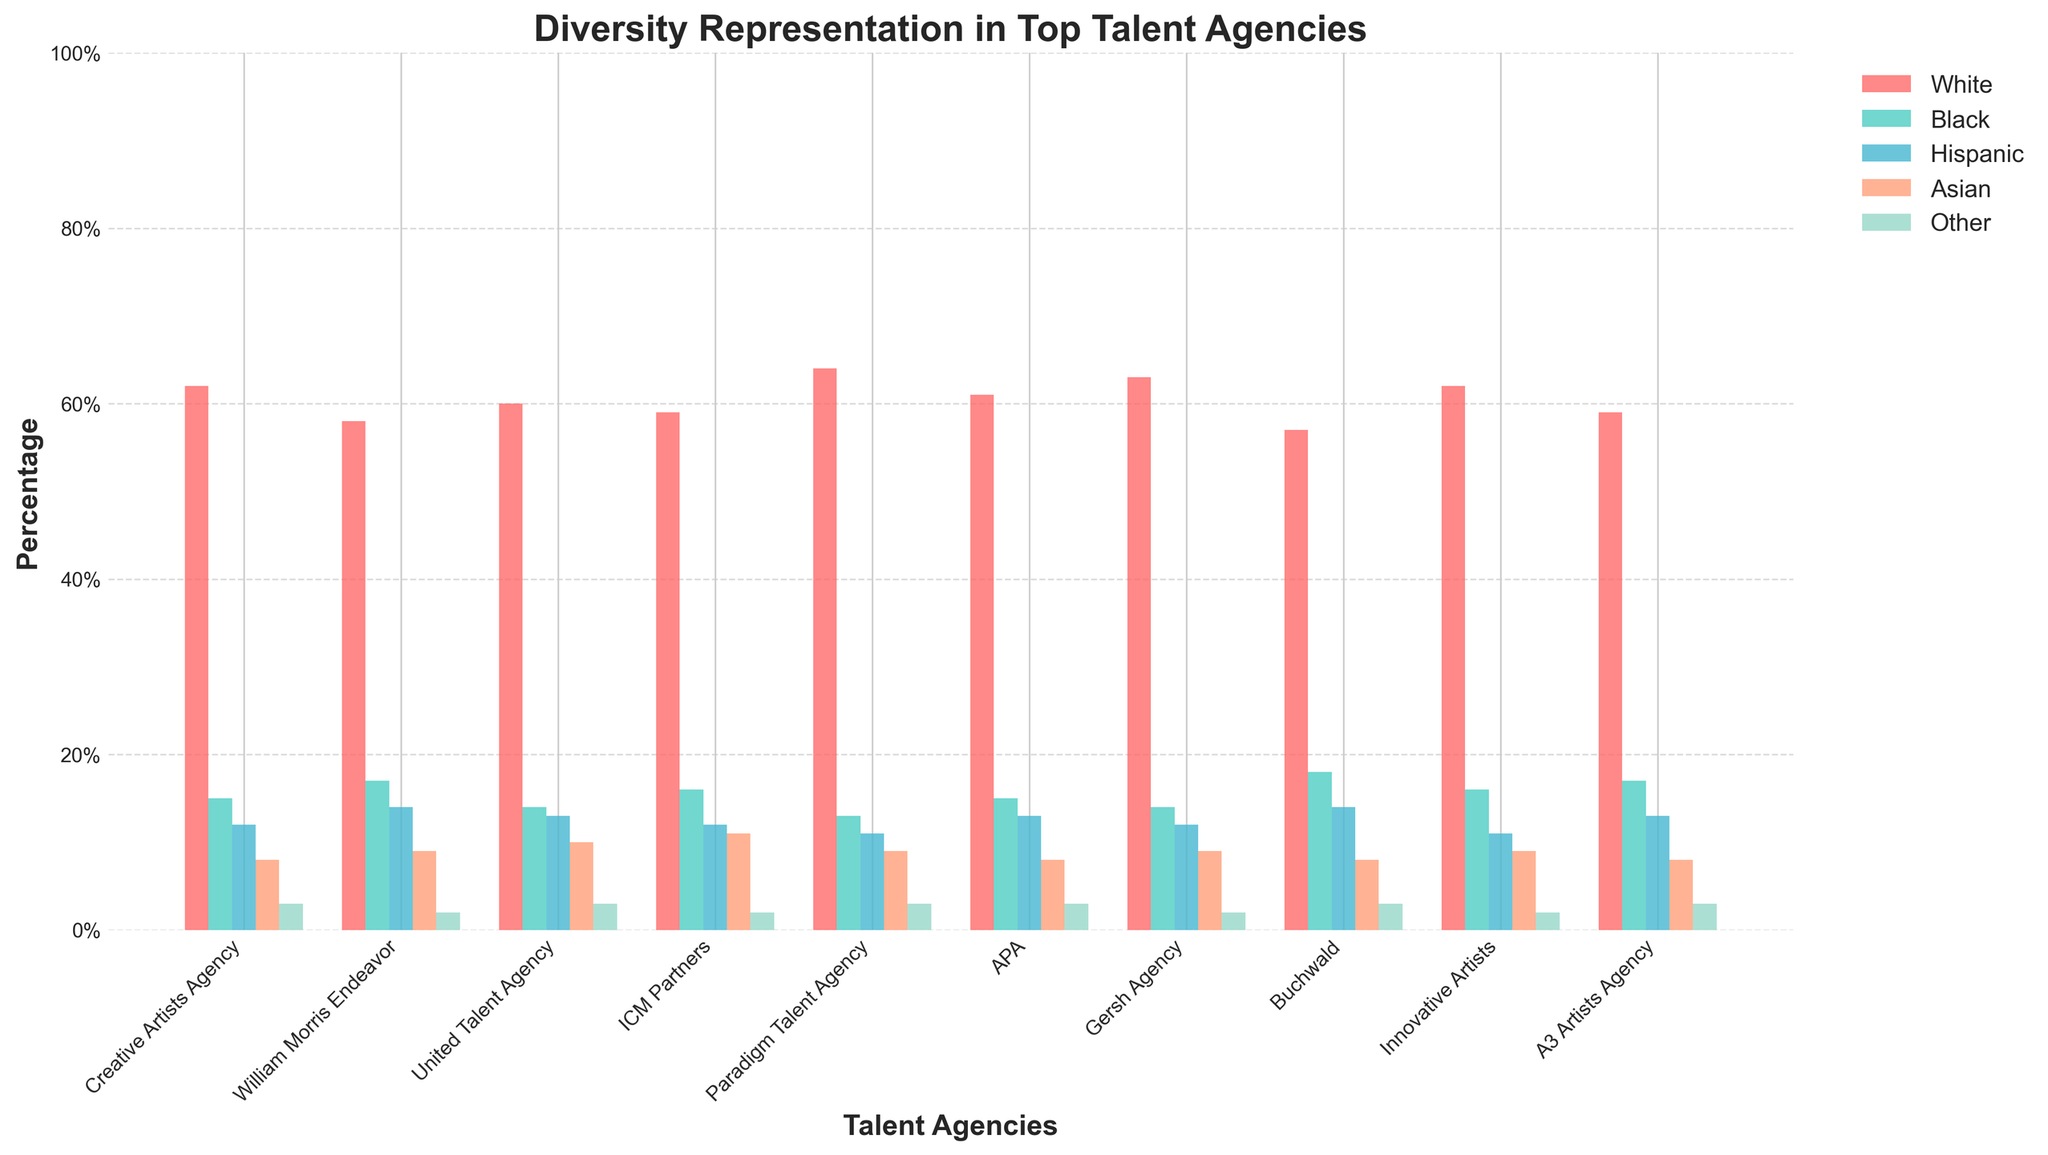Which talent agency has the highest percentage of White representation? By comparing the heights of the bars representing White representation for all talent agencies, it's apparent that Paradigm Talent Agency has the highest percentage, with a bar reaching the 64% mark
Answer: Paradigm Talent Agency What is the difference in Asian representation between the agency with the highest and lowest percentages? Comparing the Asian representation bars, the highest is ICM Partners with 11% and the lowest is a tie between Creative Artists Agency and APA with 8%, the difference is 11% - 8% = 3%
Answer: 3% Which demographic group is the smallest across all agencies? By observing the color-coded bars for all demographic groups across agencies, the 'Other' group consistently has the shortest bars among all categories
Answer: Other For Buchwald, what is the total percentage of non-White representation? Sum the percentages of Black, Hispanic, Asian, and Other representation in Buchwald, which are 18%, 14%, 8%, and 3%, respectively. The total is 18% + 14% + 8% + 3% = 43%
Answer: 43% Which agency has the closest White and Black representation percentages? By comparing the two bars (White and Black) for each agency, Buchwald has the closest percentages, with White at 57% and Black at 18%, making the difference 57% - 18% = 39%. This is smaller compared to other agencies
Answer: Buchwald What is the average percentage of Hispanic representation across all agencies? Sum the Hispanic representation percentages for all agencies: (12% + 14% + 13% + 12% + 11% + 13% + 12% + 14% + 11% + 13%) and divide by the number of agencies (10). Sum = 125%, Average = 125% / 10 = 12.5%
Answer: 12.5% How does the Black representation at APA compare to that at United Talent Agency? Comparing the heights of the Black representation bars, APA stands at 15%, while United Talent Agency stands at 14%, making APA's Black representation 1% higher than United Talent Agency
Answer: 1% higher Which agency shows the most diversity in demographic representation? By visually assessing the balance and variability in bar heights for all demographic groups, Buchwald stands out as it has the most evenly distributed and elevated percentages across Black (18%), Hispanic (14%), and Other (3%).
Answer: Buchwald Is there any agency where the combined percentage of Hispanic and Asian representation exceeds the White representation? Assess each agency's total for Hispanic and Asian representation and compare it to their White representation. All agencies' combined Hispanic and Asian percentages are lower than their White percentages. For instance, creative artists have combined 20% (12%+8%) less than 62% White
Answer: No 